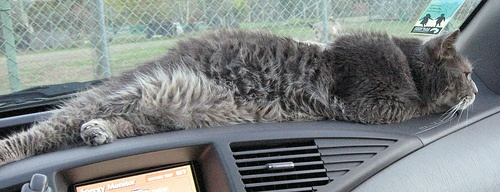Describe the objects in this image and their specific colors. I can see car in darkgray, gray, black, lightgray, and lightblue tones and cat in darkgray, gray, black, and lightgray tones in this image. 